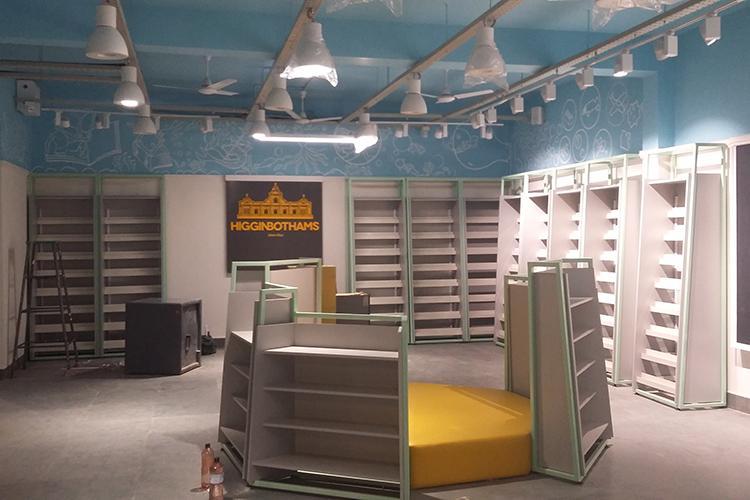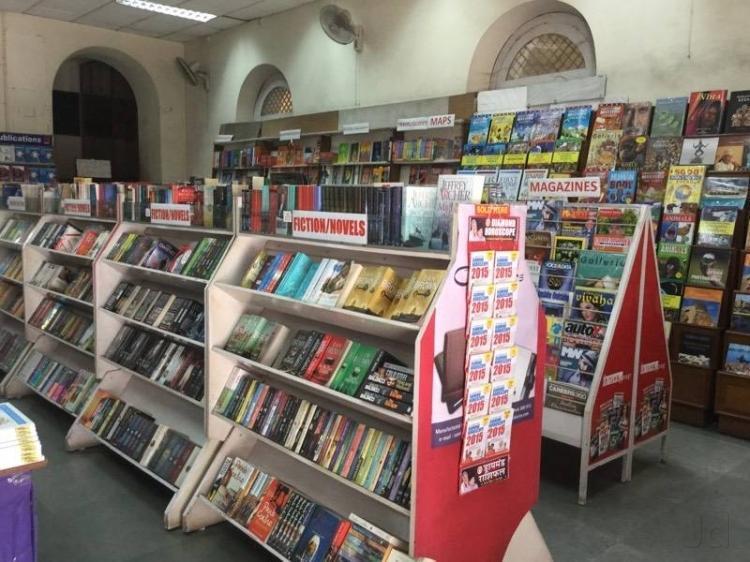The first image is the image on the left, the second image is the image on the right. Given the left and right images, does the statement "The right image shows an arched opening at the left end of a row of shelves in a shop's interior." hold true? Answer yes or no. Yes. The first image is the image on the left, the second image is the image on the right. Given the left and right images, does the statement "Although the image to the left is a bookstore, there are no actual books visible." hold true? Answer yes or no. Yes. 